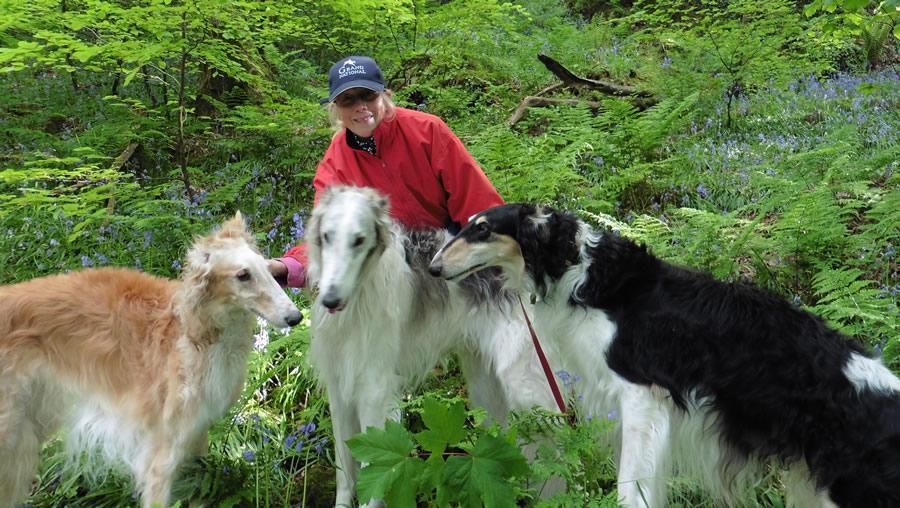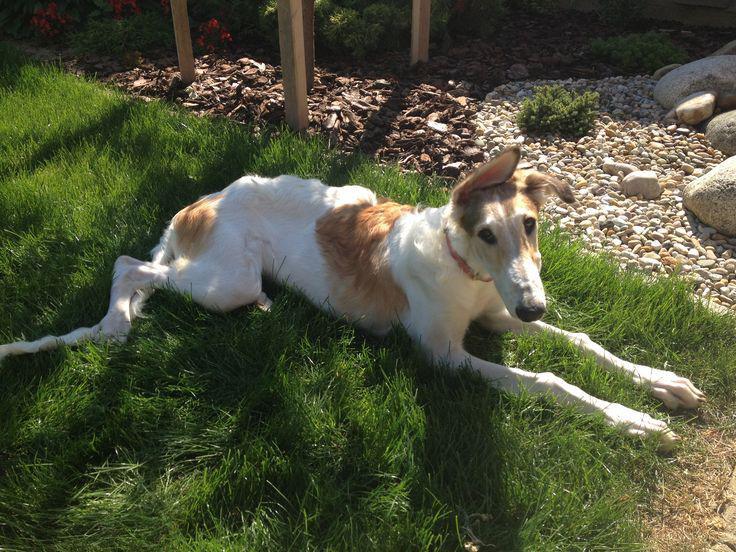The first image is the image on the left, the second image is the image on the right. For the images displayed, is the sentence "Each image shows exactly two furry hounds posed next to each other outdoors on grass." factually correct? Answer yes or no. No. The first image is the image on the left, the second image is the image on the right. Examine the images to the left and right. Is the description "There are two dogs in each image." accurate? Answer yes or no. No. 